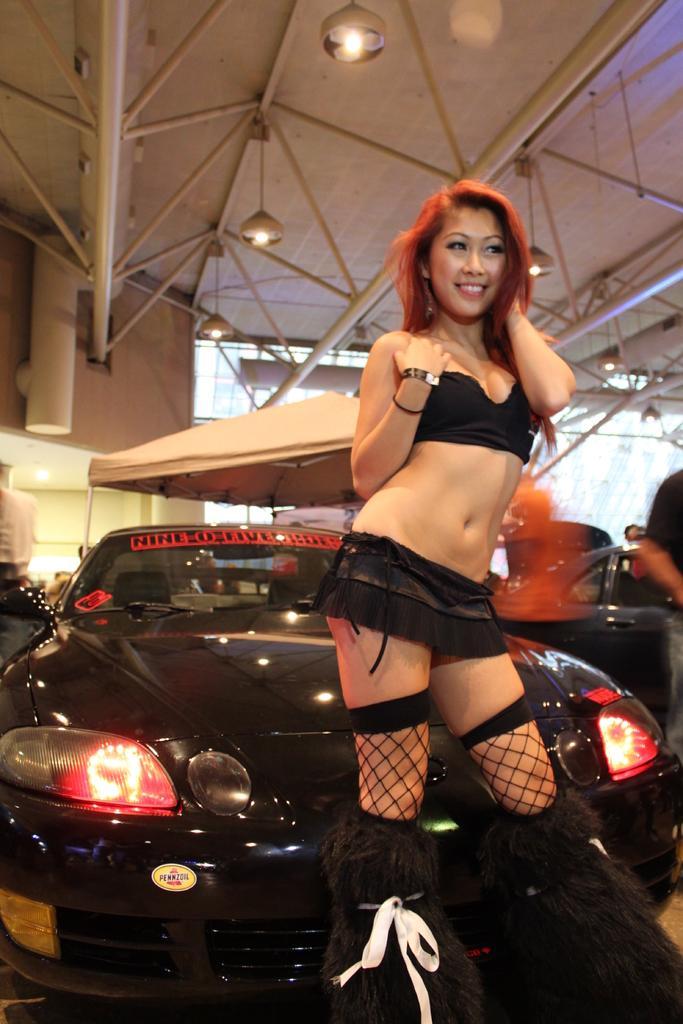Describe this image in one or two sentences. In the center of the image there is a woman standing on the ground. In the background we can see cars, tent, lights, roof and wall. 